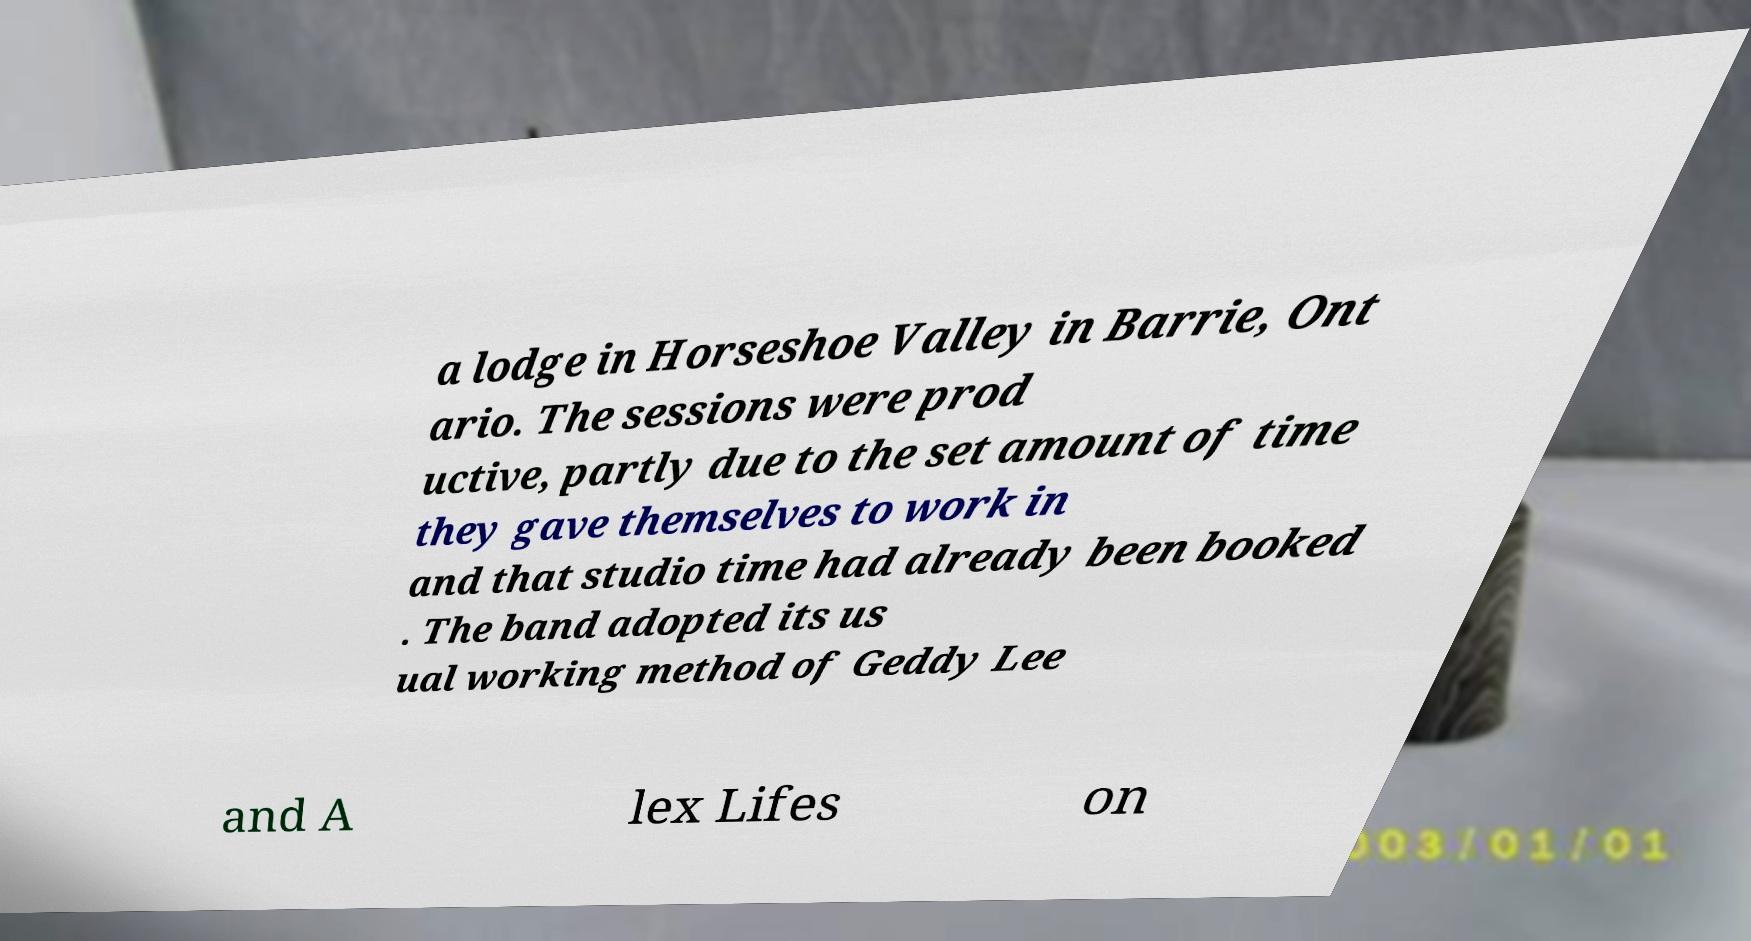Please identify and transcribe the text found in this image. a lodge in Horseshoe Valley in Barrie, Ont ario. The sessions were prod uctive, partly due to the set amount of time they gave themselves to work in and that studio time had already been booked . The band adopted its us ual working method of Geddy Lee and A lex Lifes on 